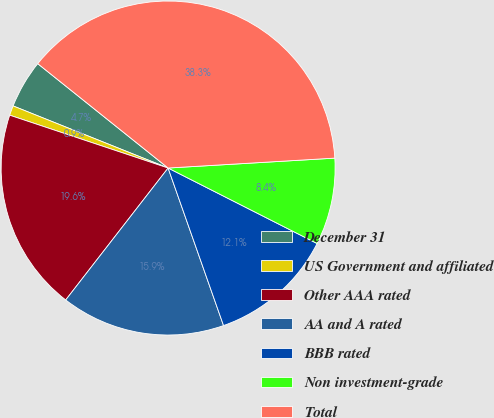Convert chart to OTSL. <chart><loc_0><loc_0><loc_500><loc_500><pie_chart><fcel>December 31<fcel>US Government and affiliated<fcel>Other AAA rated<fcel>AA and A rated<fcel>BBB rated<fcel>Non investment-grade<fcel>Total<nl><fcel>4.68%<fcel>0.94%<fcel>19.62%<fcel>15.89%<fcel>12.15%<fcel>8.41%<fcel>38.31%<nl></chart> 